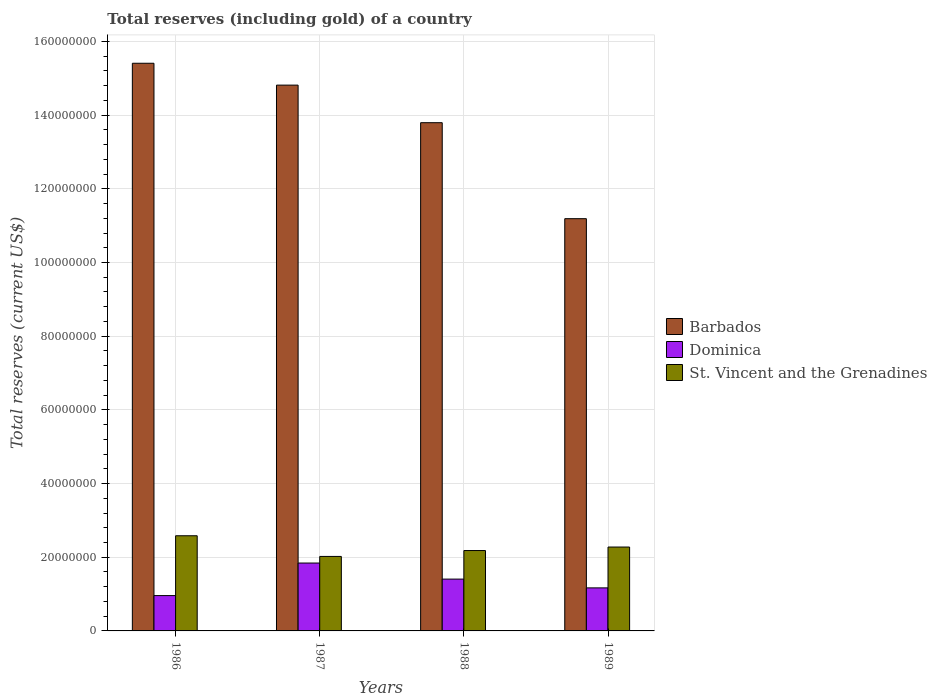How many different coloured bars are there?
Provide a short and direct response. 3. How many groups of bars are there?
Offer a terse response. 4. Are the number of bars per tick equal to the number of legend labels?
Offer a very short reply. Yes. How many bars are there on the 1st tick from the left?
Make the answer very short. 3. What is the label of the 1st group of bars from the left?
Offer a very short reply. 1986. In how many cases, is the number of bars for a given year not equal to the number of legend labels?
Offer a very short reply. 0. What is the total reserves (including gold) in St. Vincent and the Grenadines in 1988?
Keep it short and to the point. 2.18e+07. Across all years, what is the maximum total reserves (including gold) in Dominica?
Your answer should be compact. 1.84e+07. Across all years, what is the minimum total reserves (including gold) in Barbados?
Ensure brevity in your answer.  1.12e+08. In which year was the total reserves (including gold) in Barbados maximum?
Offer a very short reply. 1986. What is the total total reserves (including gold) in St. Vincent and the Grenadines in the graph?
Your answer should be very brief. 9.06e+07. What is the difference between the total reserves (including gold) in St. Vincent and the Grenadines in 1986 and that in 1988?
Ensure brevity in your answer.  4.01e+06. What is the difference between the total reserves (including gold) in Barbados in 1987 and the total reserves (including gold) in Dominica in 1989?
Make the answer very short. 1.36e+08. What is the average total reserves (including gold) in Dominica per year?
Offer a terse response. 1.34e+07. In the year 1988, what is the difference between the total reserves (including gold) in Barbados and total reserves (including gold) in Dominica?
Keep it short and to the point. 1.24e+08. In how many years, is the total reserves (including gold) in Barbados greater than 136000000 US$?
Your response must be concise. 3. What is the ratio of the total reserves (including gold) in Barbados in 1987 to that in 1989?
Give a very brief answer. 1.32. Is the total reserves (including gold) in Barbados in 1986 less than that in 1987?
Your response must be concise. No. What is the difference between the highest and the second highest total reserves (including gold) in Dominica?
Your answer should be compact. 4.36e+06. What is the difference between the highest and the lowest total reserves (including gold) in Dominica?
Your answer should be compact. 8.83e+06. Is the sum of the total reserves (including gold) in St. Vincent and the Grenadines in 1986 and 1988 greater than the maximum total reserves (including gold) in Barbados across all years?
Provide a short and direct response. No. What does the 3rd bar from the left in 1989 represents?
Offer a terse response. St. Vincent and the Grenadines. What does the 3rd bar from the right in 1986 represents?
Offer a terse response. Barbados. Is it the case that in every year, the sum of the total reserves (including gold) in Dominica and total reserves (including gold) in St. Vincent and the Grenadines is greater than the total reserves (including gold) in Barbados?
Your answer should be very brief. No. Does the graph contain any zero values?
Provide a succinct answer. No. Where does the legend appear in the graph?
Offer a terse response. Center right. What is the title of the graph?
Your answer should be compact. Total reserves (including gold) of a country. What is the label or title of the X-axis?
Give a very brief answer. Years. What is the label or title of the Y-axis?
Offer a terse response. Total reserves (current US$). What is the Total reserves (current US$) in Barbados in 1986?
Offer a very short reply. 1.54e+08. What is the Total reserves (current US$) in Dominica in 1986?
Keep it short and to the point. 9.59e+06. What is the Total reserves (current US$) in St. Vincent and the Grenadines in 1986?
Ensure brevity in your answer.  2.58e+07. What is the Total reserves (current US$) of Barbados in 1987?
Keep it short and to the point. 1.48e+08. What is the Total reserves (current US$) in Dominica in 1987?
Offer a terse response. 1.84e+07. What is the Total reserves (current US$) in St. Vincent and the Grenadines in 1987?
Give a very brief answer. 2.02e+07. What is the Total reserves (current US$) in Barbados in 1988?
Offer a terse response. 1.38e+08. What is the Total reserves (current US$) in Dominica in 1988?
Offer a very short reply. 1.41e+07. What is the Total reserves (current US$) in St. Vincent and the Grenadines in 1988?
Offer a terse response. 2.18e+07. What is the Total reserves (current US$) in Barbados in 1989?
Keep it short and to the point. 1.12e+08. What is the Total reserves (current US$) of Dominica in 1989?
Provide a succinct answer. 1.17e+07. What is the Total reserves (current US$) of St. Vincent and the Grenadines in 1989?
Offer a terse response. 2.28e+07. Across all years, what is the maximum Total reserves (current US$) in Barbados?
Give a very brief answer. 1.54e+08. Across all years, what is the maximum Total reserves (current US$) of Dominica?
Give a very brief answer. 1.84e+07. Across all years, what is the maximum Total reserves (current US$) of St. Vincent and the Grenadines?
Ensure brevity in your answer.  2.58e+07. Across all years, what is the minimum Total reserves (current US$) in Barbados?
Give a very brief answer. 1.12e+08. Across all years, what is the minimum Total reserves (current US$) of Dominica?
Provide a short and direct response. 9.59e+06. Across all years, what is the minimum Total reserves (current US$) of St. Vincent and the Grenadines?
Give a very brief answer. 2.02e+07. What is the total Total reserves (current US$) in Barbados in the graph?
Offer a terse response. 5.52e+08. What is the total Total reserves (current US$) of Dominica in the graph?
Provide a succinct answer. 5.38e+07. What is the total Total reserves (current US$) of St. Vincent and the Grenadines in the graph?
Offer a terse response. 9.06e+07. What is the difference between the Total reserves (current US$) in Barbados in 1986 and that in 1987?
Your answer should be compact. 5.94e+06. What is the difference between the Total reserves (current US$) in Dominica in 1986 and that in 1987?
Your response must be concise. -8.83e+06. What is the difference between the Total reserves (current US$) of St. Vincent and the Grenadines in 1986 and that in 1987?
Make the answer very short. 5.61e+06. What is the difference between the Total reserves (current US$) in Barbados in 1986 and that in 1988?
Provide a short and direct response. 1.61e+07. What is the difference between the Total reserves (current US$) in Dominica in 1986 and that in 1988?
Give a very brief answer. -4.47e+06. What is the difference between the Total reserves (current US$) in St. Vincent and the Grenadines in 1986 and that in 1988?
Offer a very short reply. 4.01e+06. What is the difference between the Total reserves (current US$) in Barbados in 1986 and that in 1989?
Offer a terse response. 4.22e+07. What is the difference between the Total reserves (current US$) of Dominica in 1986 and that in 1989?
Offer a terse response. -2.09e+06. What is the difference between the Total reserves (current US$) of St. Vincent and the Grenadines in 1986 and that in 1989?
Provide a short and direct response. 3.06e+06. What is the difference between the Total reserves (current US$) in Barbados in 1987 and that in 1988?
Your answer should be very brief. 1.02e+07. What is the difference between the Total reserves (current US$) in Dominica in 1987 and that in 1988?
Ensure brevity in your answer.  4.36e+06. What is the difference between the Total reserves (current US$) in St. Vincent and the Grenadines in 1987 and that in 1988?
Your answer should be very brief. -1.60e+06. What is the difference between the Total reserves (current US$) in Barbados in 1987 and that in 1989?
Make the answer very short. 3.63e+07. What is the difference between the Total reserves (current US$) of Dominica in 1987 and that in 1989?
Keep it short and to the point. 6.74e+06. What is the difference between the Total reserves (current US$) in St. Vincent and the Grenadines in 1987 and that in 1989?
Offer a terse response. -2.55e+06. What is the difference between the Total reserves (current US$) of Barbados in 1988 and that in 1989?
Keep it short and to the point. 2.61e+07. What is the difference between the Total reserves (current US$) of Dominica in 1988 and that in 1989?
Provide a succinct answer. 2.38e+06. What is the difference between the Total reserves (current US$) of St. Vincent and the Grenadines in 1988 and that in 1989?
Provide a short and direct response. -9.50e+05. What is the difference between the Total reserves (current US$) in Barbados in 1986 and the Total reserves (current US$) in Dominica in 1987?
Offer a very short reply. 1.36e+08. What is the difference between the Total reserves (current US$) in Barbados in 1986 and the Total reserves (current US$) in St. Vincent and the Grenadines in 1987?
Give a very brief answer. 1.34e+08. What is the difference between the Total reserves (current US$) in Dominica in 1986 and the Total reserves (current US$) in St. Vincent and the Grenadines in 1987?
Provide a succinct answer. -1.06e+07. What is the difference between the Total reserves (current US$) in Barbados in 1986 and the Total reserves (current US$) in Dominica in 1988?
Offer a very short reply. 1.40e+08. What is the difference between the Total reserves (current US$) of Barbados in 1986 and the Total reserves (current US$) of St. Vincent and the Grenadines in 1988?
Provide a succinct answer. 1.32e+08. What is the difference between the Total reserves (current US$) in Dominica in 1986 and the Total reserves (current US$) in St. Vincent and the Grenadines in 1988?
Your response must be concise. -1.22e+07. What is the difference between the Total reserves (current US$) in Barbados in 1986 and the Total reserves (current US$) in Dominica in 1989?
Keep it short and to the point. 1.42e+08. What is the difference between the Total reserves (current US$) in Barbados in 1986 and the Total reserves (current US$) in St. Vincent and the Grenadines in 1989?
Give a very brief answer. 1.31e+08. What is the difference between the Total reserves (current US$) of Dominica in 1986 and the Total reserves (current US$) of St. Vincent and the Grenadines in 1989?
Offer a very short reply. -1.32e+07. What is the difference between the Total reserves (current US$) of Barbados in 1987 and the Total reserves (current US$) of Dominica in 1988?
Provide a succinct answer. 1.34e+08. What is the difference between the Total reserves (current US$) of Barbados in 1987 and the Total reserves (current US$) of St. Vincent and the Grenadines in 1988?
Provide a succinct answer. 1.26e+08. What is the difference between the Total reserves (current US$) in Dominica in 1987 and the Total reserves (current US$) in St. Vincent and the Grenadines in 1988?
Make the answer very short. -3.39e+06. What is the difference between the Total reserves (current US$) in Barbados in 1987 and the Total reserves (current US$) in Dominica in 1989?
Your answer should be compact. 1.36e+08. What is the difference between the Total reserves (current US$) of Barbados in 1987 and the Total reserves (current US$) of St. Vincent and the Grenadines in 1989?
Provide a succinct answer. 1.25e+08. What is the difference between the Total reserves (current US$) of Dominica in 1987 and the Total reserves (current US$) of St. Vincent and the Grenadines in 1989?
Your response must be concise. -4.34e+06. What is the difference between the Total reserves (current US$) in Barbados in 1988 and the Total reserves (current US$) in Dominica in 1989?
Give a very brief answer. 1.26e+08. What is the difference between the Total reserves (current US$) in Barbados in 1988 and the Total reserves (current US$) in St. Vincent and the Grenadines in 1989?
Your response must be concise. 1.15e+08. What is the difference between the Total reserves (current US$) of Dominica in 1988 and the Total reserves (current US$) of St. Vincent and the Grenadines in 1989?
Provide a short and direct response. -8.71e+06. What is the average Total reserves (current US$) of Barbados per year?
Keep it short and to the point. 1.38e+08. What is the average Total reserves (current US$) of Dominica per year?
Keep it short and to the point. 1.34e+07. What is the average Total reserves (current US$) in St. Vincent and the Grenadines per year?
Provide a short and direct response. 2.27e+07. In the year 1986, what is the difference between the Total reserves (current US$) of Barbados and Total reserves (current US$) of Dominica?
Ensure brevity in your answer.  1.44e+08. In the year 1986, what is the difference between the Total reserves (current US$) in Barbados and Total reserves (current US$) in St. Vincent and the Grenadines?
Ensure brevity in your answer.  1.28e+08. In the year 1986, what is the difference between the Total reserves (current US$) of Dominica and Total reserves (current US$) of St. Vincent and the Grenadines?
Offer a terse response. -1.62e+07. In the year 1987, what is the difference between the Total reserves (current US$) in Barbados and Total reserves (current US$) in Dominica?
Ensure brevity in your answer.  1.30e+08. In the year 1987, what is the difference between the Total reserves (current US$) of Barbados and Total reserves (current US$) of St. Vincent and the Grenadines?
Offer a terse response. 1.28e+08. In the year 1987, what is the difference between the Total reserves (current US$) in Dominica and Total reserves (current US$) in St. Vincent and the Grenadines?
Make the answer very short. -1.79e+06. In the year 1988, what is the difference between the Total reserves (current US$) of Barbados and Total reserves (current US$) of Dominica?
Offer a terse response. 1.24e+08. In the year 1988, what is the difference between the Total reserves (current US$) in Barbados and Total reserves (current US$) in St. Vincent and the Grenadines?
Provide a succinct answer. 1.16e+08. In the year 1988, what is the difference between the Total reserves (current US$) in Dominica and Total reserves (current US$) in St. Vincent and the Grenadines?
Keep it short and to the point. -7.76e+06. In the year 1989, what is the difference between the Total reserves (current US$) of Barbados and Total reserves (current US$) of Dominica?
Provide a short and direct response. 1.00e+08. In the year 1989, what is the difference between the Total reserves (current US$) of Barbados and Total reserves (current US$) of St. Vincent and the Grenadines?
Provide a succinct answer. 8.91e+07. In the year 1989, what is the difference between the Total reserves (current US$) in Dominica and Total reserves (current US$) in St. Vincent and the Grenadines?
Provide a short and direct response. -1.11e+07. What is the ratio of the Total reserves (current US$) in Barbados in 1986 to that in 1987?
Offer a terse response. 1.04. What is the ratio of the Total reserves (current US$) of Dominica in 1986 to that in 1987?
Keep it short and to the point. 0.52. What is the ratio of the Total reserves (current US$) in St. Vincent and the Grenadines in 1986 to that in 1987?
Keep it short and to the point. 1.28. What is the ratio of the Total reserves (current US$) of Barbados in 1986 to that in 1988?
Provide a short and direct response. 1.12. What is the ratio of the Total reserves (current US$) in Dominica in 1986 to that in 1988?
Your response must be concise. 0.68. What is the ratio of the Total reserves (current US$) in St. Vincent and the Grenadines in 1986 to that in 1988?
Give a very brief answer. 1.18. What is the ratio of the Total reserves (current US$) of Barbados in 1986 to that in 1989?
Your answer should be very brief. 1.38. What is the ratio of the Total reserves (current US$) of Dominica in 1986 to that in 1989?
Ensure brevity in your answer.  0.82. What is the ratio of the Total reserves (current US$) of St. Vincent and the Grenadines in 1986 to that in 1989?
Offer a terse response. 1.13. What is the ratio of the Total reserves (current US$) in Barbados in 1987 to that in 1988?
Provide a succinct answer. 1.07. What is the ratio of the Total reserves (current US$) of Dominica in 1987 to that in 1988?
Provide a short and direct response. 1.31. What is the ratio of the Total reserves (current US$) in St. Vincent and the Grenadines in 1987 to that in 1988?
Provide a succinct answer. 0.93. What is the ratio of the Total reserves (current US$) of Barbados in 1987 to that in 1989?
Your response must be concise. 1.32. What is the ratio of the Total reserves (current US$) of Dominica in 1987 to that in 1989?
Keep it short and to the point. 1.58. What is the ratio of the Total reserves (current US$) of St. Vincent and the Grenadines in 1987 to that in 1989?
Offer a very short reply. 0.89. What is the ratio of the Total reserves (current US$) in Barbados in 1988 to that in 1989?
Your answer should be compact. 1.23. What is the ratio of the Total reserves (current US$) of Dominica in 1988 to that in 1989?
Ensure brevity in your answer.  1.2. What is the difference between the highest and the second highest Total reserves (current US$) of Barbados?
Your response must be concise. 5.94e+06. What is the difference between the highest and the second highest Total reserves (current US$) of Dominica?
Your answer should be compact. 4.36e+06. What is the difference between the highest and the second highest Total reserves (current US$) of St. Vincent and the Grenadines?
Give a very brief answer. 3.06e+06. What is the difference between the highest and the lowest Total reserves (current US$) of Barbados?
Offer a terse response. 4.22e+07. What is the difference between the highest and the lowest Total reserves (current US$) in Dominica?
Give a very brief answer. 8.83e+06. What is the difference between the highest and the lowest Total reserves (current US$) of St. Vincent and the Grenadines?
Provide a short and direct response. 5.61e+06. 